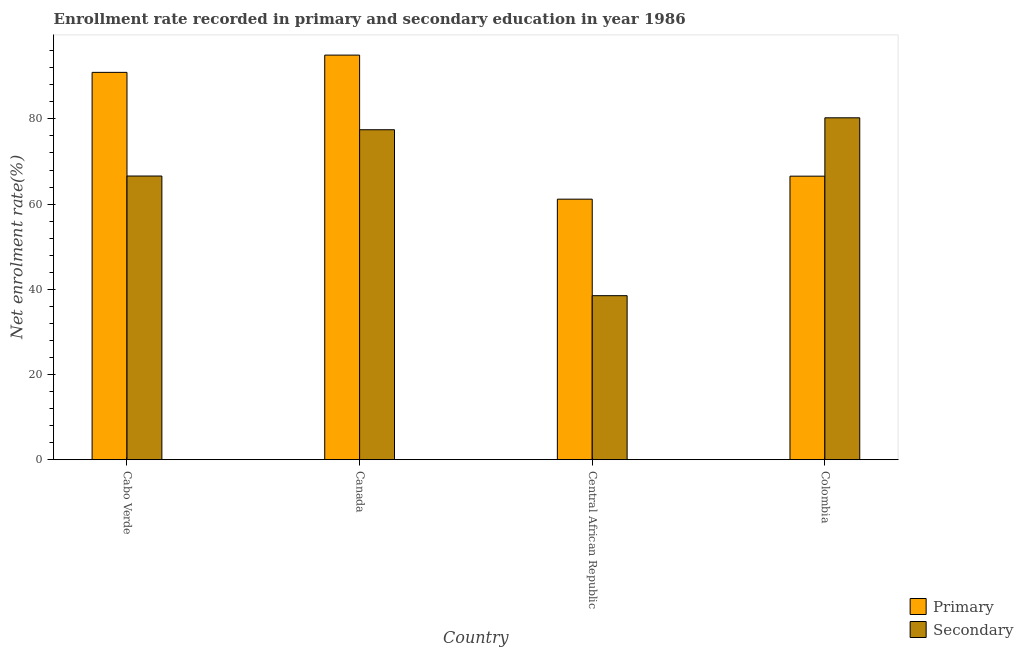How many different coloured bars are there?
Offer a terse response. 2. How many groups of bars are there?
Give a very brief answer. 4. Are the number of bars per tick equal to the number of legend labels?
Ensure brevity in your answer.  Yes. Are the number of bars on each tick of the X-axis equal?
Provide a short and direct response. Yes. What is the label of the 2nd group of bars from the left?
Offer a terse response. Canada. What is the enrollment rate in primary education in Cabo Verde?
Ensure brevity in your answer.  90.93. Across all countries, what is the maximum enrollment rate in primary education?
Ensure brevity in your answer.  94.98. Across all countries, what is the minimum enrollment rate in secondary education?
Your answer should be very brief. 38.51. In which country was the enrollment rate in secondary education maximum?
Your answer should be very brief. Colombia. In which country was the enrollment rate in primary education minimum?
Give a very brief answer. Central African Republic. What is the total enrollment rate in secondary education in the graph?
Keep it short and to the point. 262.82. What is the difference between the enrollment rate in primary education in Canada and that in Colombia?
Ensure brevity in your answer.  28.42. What is the difference between the enrollment rate in secondary education in Canada and the enrollment rate in primary education in Central African Republic?
Give a very brief answer. 16.3. What is the average enrollment rate in primary education per country?
Your answer should be very brief. 78.41. What is the difference between the enrollment rate in secondary education and enrollment rate in primary education in Canada?
Give a very brief answer. -17.52. What is the ratio of the enrollment rate in primary education in Cabo Verde to that in Colombia?
Offer a very short reply. 1.37. Is the enrollment rate in primary education in Cabo Verde less than that in Canada?
Provide a short and direct response. Yes. What is the difference between the highest and the second highest enrollment rate in primary education?
Provide a succinct answer. 4.05. What is the difference between the highest and the lowest enrollment rate in secondary education?
Your answer should be very brief. 41.75. In how many countries, is the enrollment rate in secondary education greater than the average enrollment rate in secondary education taken over all countries?
Your answer should be very brief. 3. Is the sum of the enrollment rate in primary education in Canada and Colombia greater than the maximum enrollment rate in secondary education across all countries?
Provide a succinct answer. Yes. What does the 1st bar from the left in Colombia represents?
Offer a very short reply. Primary. What does the 2nd bar from the right in Central African Republic represents?
Provide a short and direct response. Primary. Are all the bars in the graph horizontal?
Make the answer very short. No. How many countries are there in the graph?
Ensure brevity in your answer.  4. Where does the legend appear in the graph?
Provide a short and direct response. Bottom right. How many legend labels are there?
Provide a short and direct response. 2. How are the legend labels stacked?
Provide a short and direct response. Vertical. What is the title of the graph?
Provide a short and direct response. Enrollment rate recorded in primary and secondary education in year 1986. Does "Official creditors" appear as one of the legend labels in the graph?
Make the answer very short. No. What is the label or title of the X-axis?
Ensure brevity in your answer.  Country. What is the label or title of the Y-axis?
Make the answer very short. Net enrolment rate(%). What is the Net enrolment rate(%) of Primary in Cabo Verde?
Offer a very short reply. 90.93. What is the Net enrolment rate(%) of Secondary in Cabo Verde?
Your response must be concise. 66.59. What is the Net enrolment rate(%) of Primary in Canada?
Ensure brevity in your answer.  94.98. What is the Net enrolment rate(%) in Secondary in Canada?
Provide a short and direct response. 77.46. What is the Net enrolment rate(%) of Primary in Central African Republic?
Keep it short and to the point. 61.16. What is the Net enrolment rate(%) of Secondary in Central African Republic?
Your answer should be very brief. 38.51. What is the Net enrolment rate(%) of Primary in Colombia?
Make the answer very short. 66.56. What is the Net enrolment rate(%) in Secondary in Colombia?
Offer a terse response. 80.26. Across all countries, what is the maximum Net enrolment rate(%) of Primary?
Your answer should be very brief. 94.98. Across all countries, what is the maximum Net enrolment rate(%) in Secondary?
Provide a succinct answer. 80.26. Across all countries, what is the minimum Net enrolment rate(%) of Primary?
Your response must be concise. 61.16. Across all countries, what is the minimum Net enrolment rate(%) of Secondary?
Make the answer very short. 38.51. What is the total Net enrolment rate(%) in Primary in the graph?
Keep it short and to the point. 313.63. What is the total Net enrolment rate(%) in Secondary in the graph?
Give a very brief answer. 262.82. What is the difference between the Net enrolment rate(%) of Primary in Cabo Verde and that in Canada?
Provide a succinct answer. -4.05. What is the difference between the Net enrolment rate(%) in Secondary in Cabo Verde and that in Canada?
Your answer should be very brief. -10.86. What is the difference between the Net enrolment rate(%) of Primary in Cabo Verde and that in Central African Republic?
Provide a short and direct response. 29.77. What is the difference between the Net enrolment rate(%) in Secondary in Cabo Verde and that in Central African Republic?
Your answer should be very brief. 28.09. What is the difference between the Net enrolment rate(%) of Primary in Cabo Verde and that in Colombia?
Your answer should be compact. 24.37. What is the difference between the Net enrolment rate(%) in Secondary in Cabo Verde and that in Colombia?
Offer a very short reply. -13.66. What is the difference between the Net enrolment rate(%) in Primary in Canada and that in Central African Republic?
Make the answer very short. 33.82. What is the difference between the Net enrolment rate(%) in Secondary in Canada and that in Central African Republic?
Your answer should be very brief. 38.95. What is the difference between the Net enrolment rate(%) in Primary in Canada and that in Colombia?
Your response must be concise. 28.42. What is the difference between the Net enrolment rate(%) of Secondary in Canada and that in Colombia?
Provide a short and direct response. -2.8. What is the difference between the Net enrolment rate(%) of Primary in Central African Republic and that in Colombia?
Give a very brief answer. -5.4. What is the difference between the Net enrolment rate(%) in Secondary in Central African Republic and that in Colombia?
Your response must be concise. -41.75. What is the difference between the Net enrolment rate(%) in Primary in Cabo Verde and the Net enrolment rate(%) in Secondary in Canada?
Your response must be concise. 13.47. What is the difference between the Net enrolment rate(%) of Primary in Cabo Verde and the Net enrolment rate(%) of Secondary in Central African Republic?
Offer a very short reply. 52.42. What is the difference between the Net enrolment rate(%) in Primary in Cabo Verde and the Net enrolment rate(%) in Secondary in Colombia?
Ensure brevity in your answer.  10.67. What is the difference between the Net enrolment rate(%) of Primary in Canada and the Net enrolment rate(%) of Secondary in Central African Republic?
Ensure brevity in your answer.  56.47. What is the difference between the Net enrolment rate(%) in Primary in Canada and the Net enrolment rate(%) in Secondary in Colombia?
Offer a terse response. 14.72. What is the difference between the Net enrolment rate(%) of Primary in Central African Republic and the Net enrolment rate(%) of Secondary in Colombia?
Make the answer very short. -19.1. What is the average Net enrolment rate(%) in Primary per country?
Make the answer very short. 78.41. What is the average Net enrolment rate(%) in Secondary per country?
Ensure brevity in your answer.  65.7. What is the difference between the Net enrolment rate(%) of Primary and Net enrolment rate(%) of Secondary in Cabo Verde?
Provide a succinct answer. 24.33. What is the difference between the Net enrolment rate(%) in Primary and Net enrolment rate(%) in Secondary in Canada?
Offer a terse response. 17.52. What is the difference between the Net enrolment rate(%) of Primary and Net enrolment rate(%) of Secondary in Central African Republic?
Provide a short and direct response. 22.66. What is the difference between the Net enrolment rate(%) of Primary and Net enrolment rate(%) of Secondary in Colombia?
Give a very brief answer. -13.7. What is the ratio of the Net enrolment rate(%) of Primary in Cabo Verde to that in Canada?
Provide a succinct answer. 0.96. What is the ratio of the Net enrolment rate(%) of Secondary in Cabo Verde to that in Canada?
Provide a succinct answer. 0.86. What is the ratio of the Net enrolment rate(%) of Primary in Cabo Verde to that in Central African Republic?
Your response must be concise. 1.49. What is the ratio of the Net enrolment rate(%) in Secondary in Cabo Verde to that in Central African Republic?
Offer a terse response. 1.73. What is the ratio of the Net enrolment rate(%) in Primary in Cabo Verde to that in Colombia?
Provide a short and direct response. 1.37. What is the ratio of the Net enrolment rate(%) of Secondary in Cabo Verde to that in Colombia?
Offer a very short reply. 0.83. What is the ratio of the Net enrolment rate(%) of Primary in Canada to that in Central African Republic?
Give a very brief answer. 1.55. What is the ratio of the Net enrolment rate(%) of Secondary in Canada to that in Central African Republic?
Your answer should be very brief. 2.01. What is the ratio of the Net enrolment rate(%) of Primary in Canada to that in Colombia?
Your answer should be very brief. 1.43. What is the ratio of the Net enrolment rate(%) of Secondary in Canada to that in Colombia?
Your answer should be very brief. 0.97. What is the ratio of the Net enrolment rate(%) of Primary in Central African Republic to that in Colombia?
Make the answer very short. 0.92. What is the ratio of the Net enrolment rate(%) of Secondary in Central African Republic to that in Colombia?
Keep it short and to the point. 0.48. What is the difference between the highest and the second highest Net enrolment rate(%) in Primary?
Make the answer very short. 4.05. What is the difference between the highest and the second highest Net enrolment rate(%) of Secondary?
Your answer should be compact. 2.8. What is the difference between the highest and the lowest Net enrolment rate(%) in Primary?
Your response must be concise. 33.82. What is the difference between the highest and the lowest Net enrolment rate(%) in Secondary?
Offer a terse response. 41.75. 